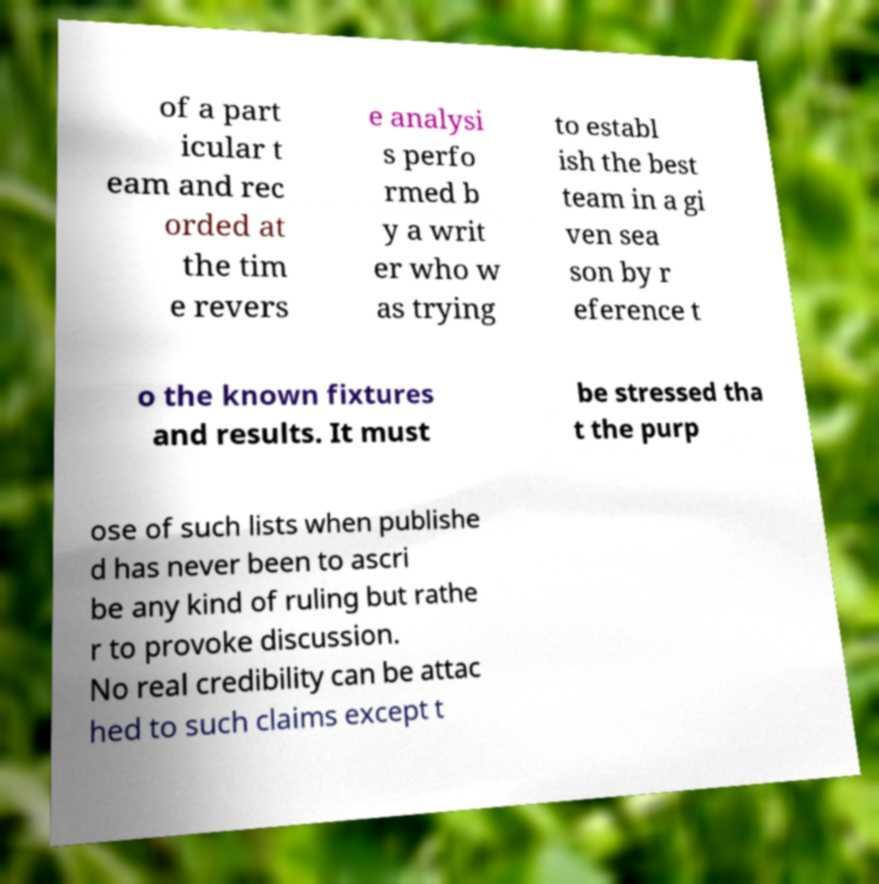Please identify and transcribe the text found in this image. of a part icular t eam and rec orded at the tim e revers e analysi s perfo rmed b y a writ er who w as trying to establ ish the best team in a gi ven sea son by r eference t o the known fixtures and results. It must be stressed tha t the purp ose of such lists when publishe d has never been to ascri be any kind of ruling but rathe r to provoke discussion. No real credibility can be attac hed to such claims except t 